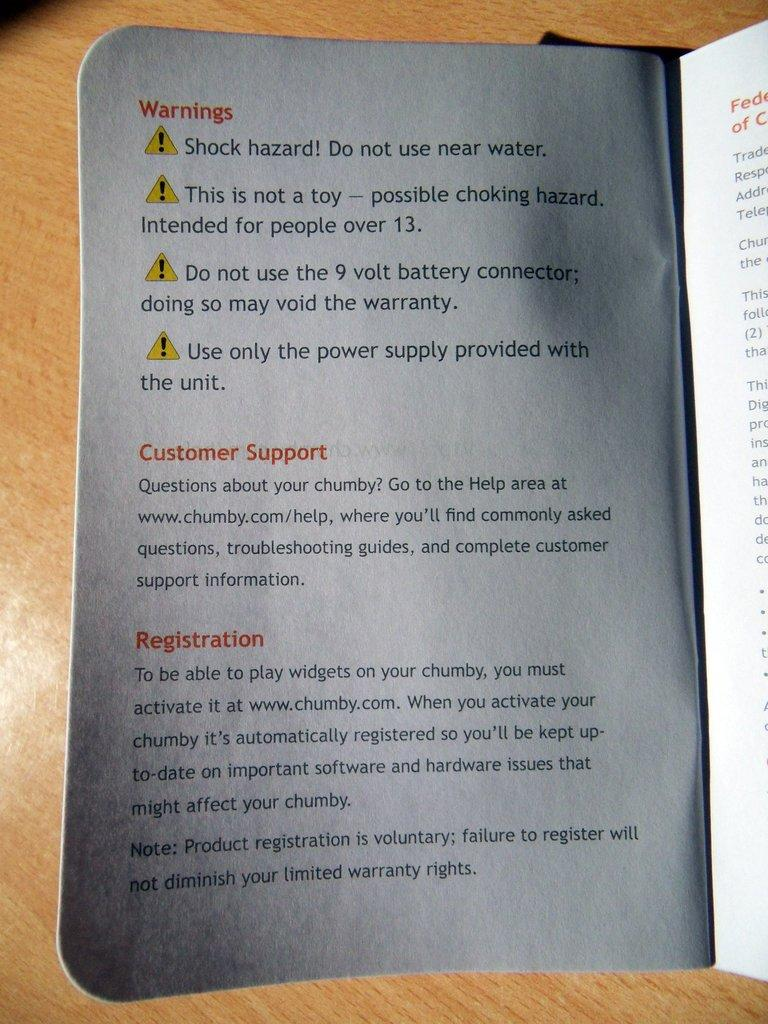<image>
Provide a brief description of the given image. an instruction booklet open to a page about WARNINGS 